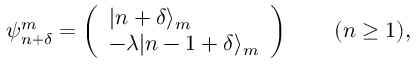Convert formula to latex. <formula><loc_0><loc_0><loc_500><loc_500>\psi _ { n + \delta } ^ { m } = \left ( \begin{array} { l } { | n + \delta \rangle _ { m } } \\ { - \lambda | n - 1 + \delta \rangle _ { m } } \end{array} \right ) \quad ( n \geq 1 ) ,</formula> 